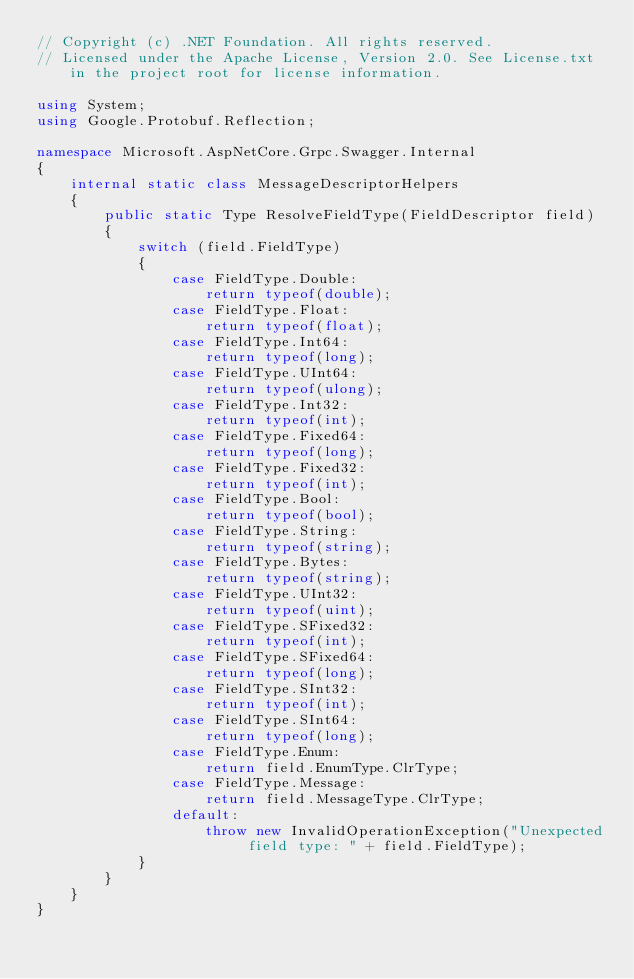<code> <loc_0><loc_0><loc_500><loc_500><_C#_>// Copyright (c) .NET Foundation. All rights reserved.
// Licensed under the Apache License, Version 2.0. See License.txt in the project root for license information.

using System;
using Google.Protobuf.Reflection;

namespace Microsoft.AspNetCore.Grpc.Swagger.Internal
{
    internal static class MessageDescriptorHelpers
    {
        public static Type ResolveFieldType(FieldDescriptor field)
        {
            switch (field.FieldType)
            {
                case FieldType.Double:
                    return typeof(double);
                case FieldType.Float:
                    return typeof(float);
                case FieldType.Int64:
                    return typeof(long);
                case FieldType.UInt64:
                    return typeof(ulong);
                case FieldType.Int32:
                    return typeof(int);
                case FieldType.Fixed64:
                    return typeof(long);
                case FieldType.Fixed32:
                    return typeof(int);
                case FieldType.Bool:
                    return typeof(bool);
                case FieldType.String:
                    return typeof(string);
                case FieldType.Bytes:
                    return typeof(string);
                case FieldType.UInt32:
                    return typeof(uint);
                case FieldType.SFixed32:
                    return typeof(int);
                case FieldType.SFixed64:
                    return typeof(long);
                case FieldType.SInt32:
                    return typeof(int);
                case FieldType.SInt64:
                    return typeof(long);
                case FieldType.Enum:
                    return field.EnumType.ClrType;
                case FieldType.Message:
                    return field.MessageType.ClrType;
                default:
                    throw new InvalidOperationException("Unexpected field type: " + field.FieldType);
            }
        }
    }
}
</code> 